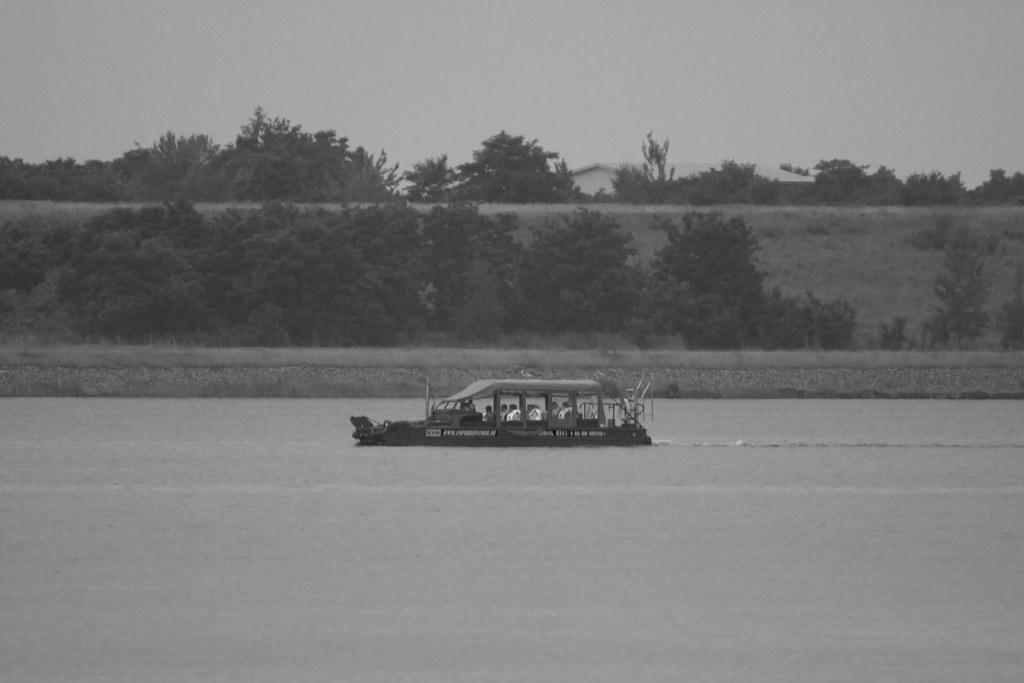Please provide a concise description of this image. In the picture we can see the water surface in it, we can see the boat and behind it, we can see some trees and behind it, we can see the path and behind it also we can see the part of the tree and in the background we can see the sky. 